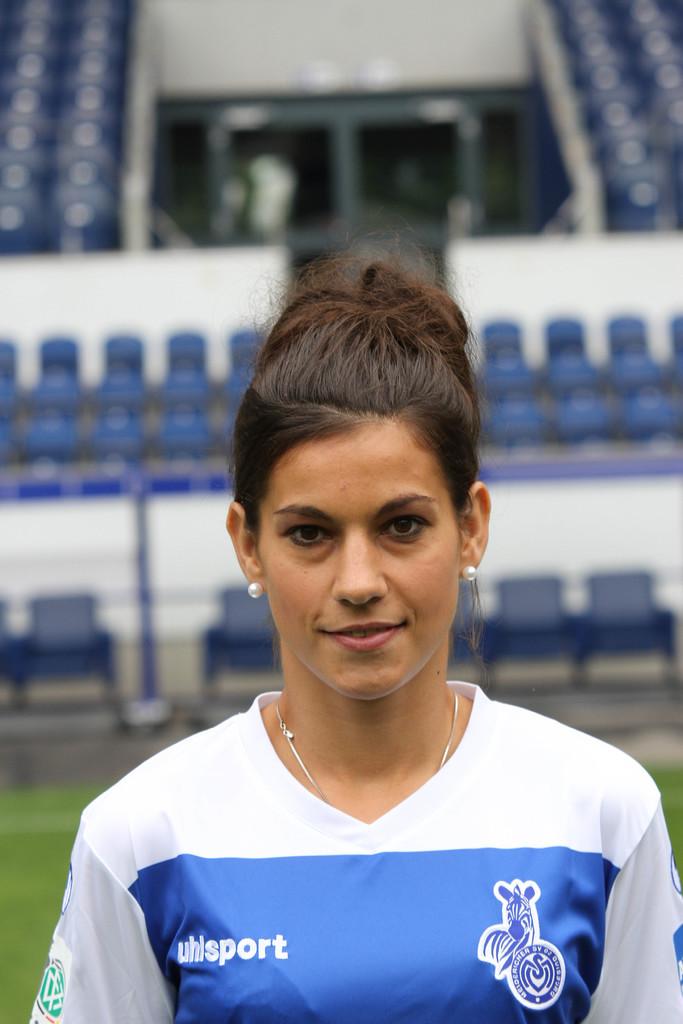What company is on her jersey?
Keep it short and to the point. Uhlsport. 